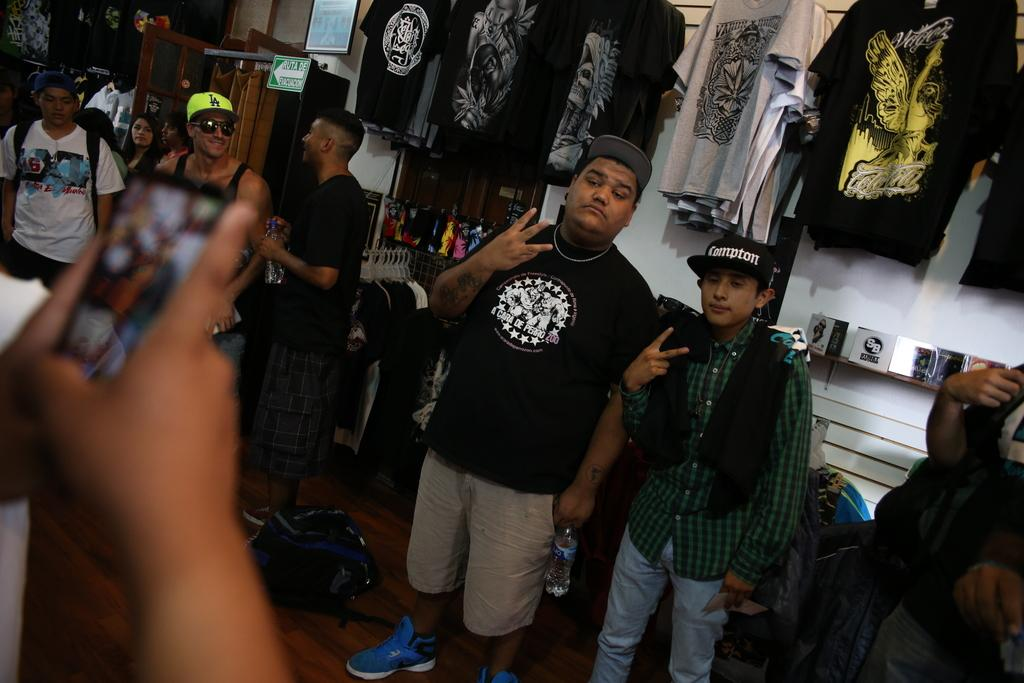Who or what is present in the image? There are people in the image. What can be seen in the background of the image? There are shirts hanging in the background of the image. What type of development is taking place in the image? There is no specific development mentioned or depicted in the image. 